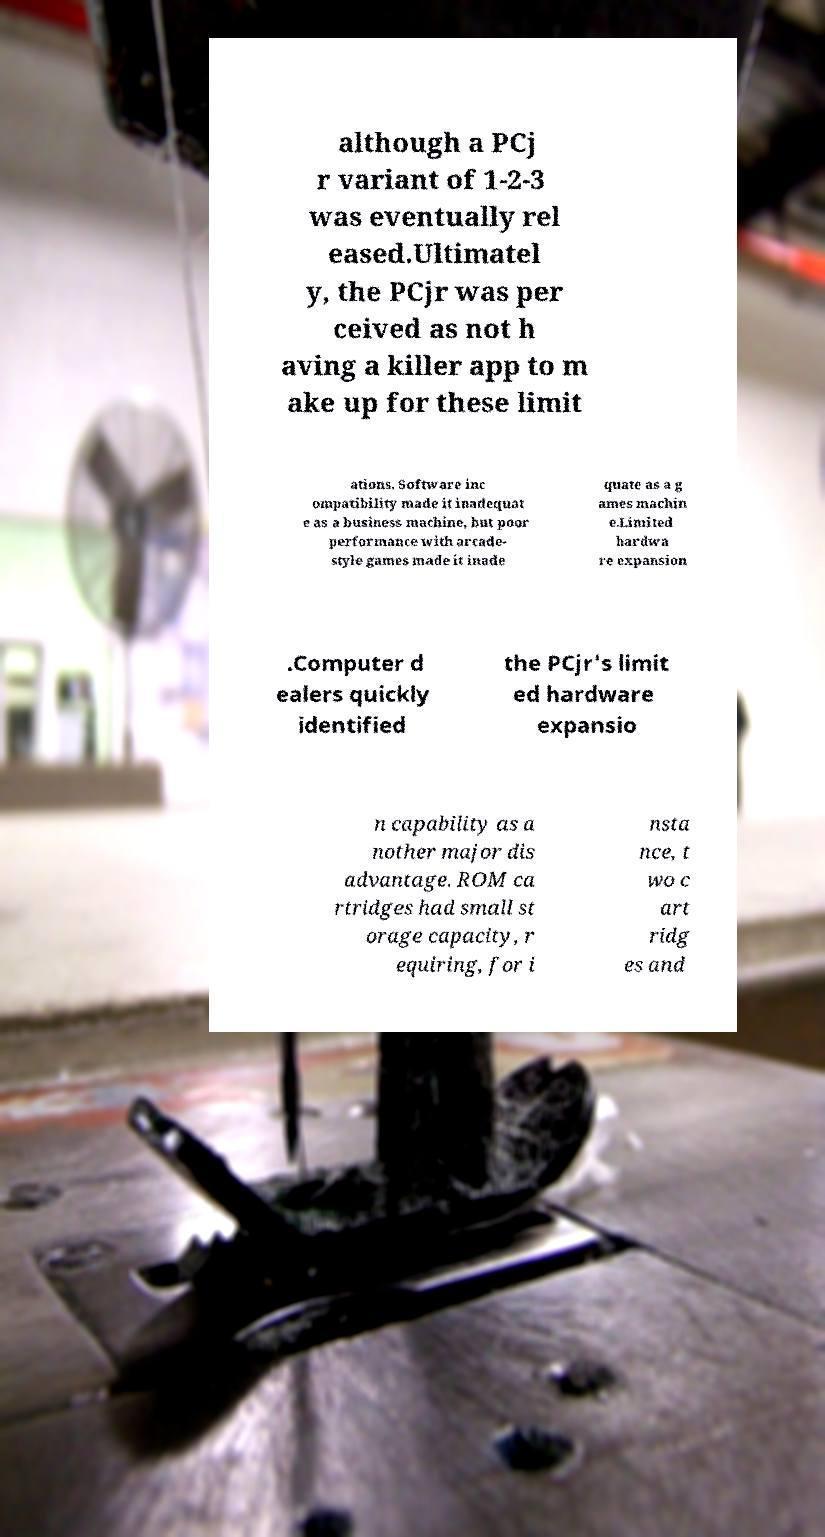What messages or text are displayed in this image? I need them in a readable, typed format. although a PCj r variant of 1-2-3 was eventually rel eased.Ultimatel y, the PCjr was per ceived as not h aving a killer app to m ake up for these limit ations. Software inc ompatibility made it inadequat e as a business machine, but poor performance with arcade- style games made it inade quate as a g ames machin e.Limited hardwa re expansion .Computer d ealers quickly identified the PCjr's limit ed hardware expansio n capability as a nother major dis advantage. ROM ca rtridges had small st orage capacity, r equiring, for i nsta nce, t wo c art ridg es and 